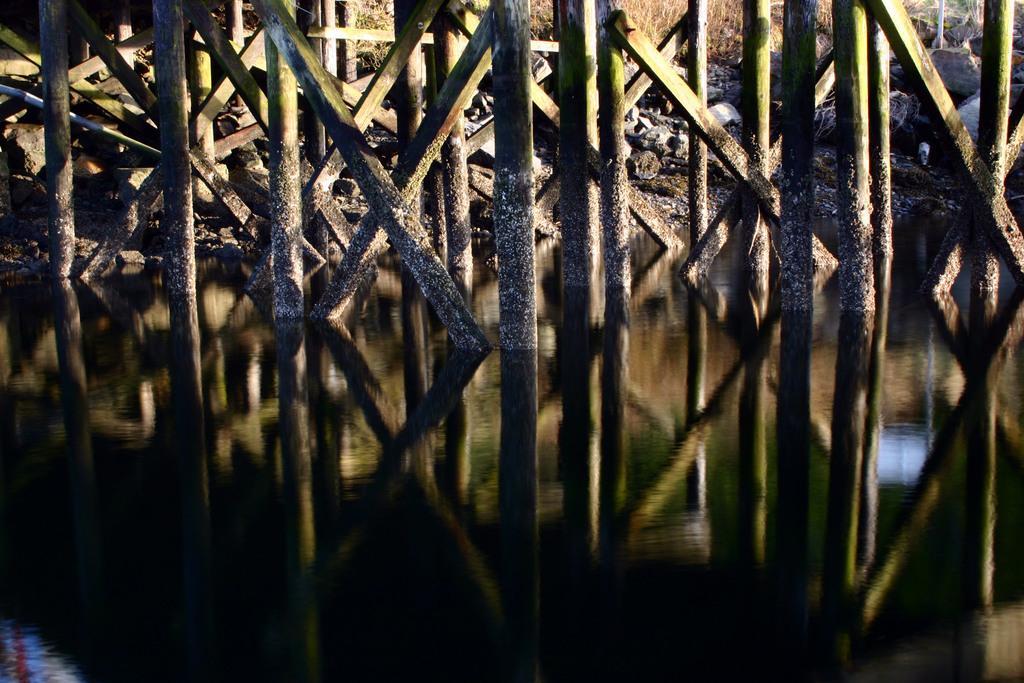Could you give a brief overview of what you see in this image? In this picture I can see water and I can see few wooden poles and few rocks. 